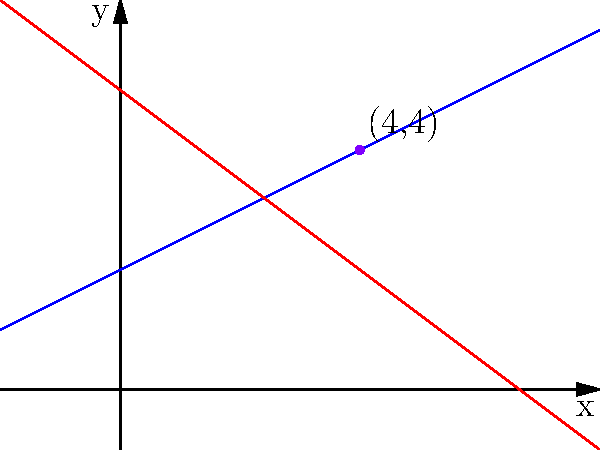In Yorgos Lanthimos' film "The Lobster," two characters' motivations can be represented by linear equations. Character A's motivation is expressed by the line $y = 0.5x + 2$, while Character B's motivation is represented by $y = -0.75x + 5$. At what point do these conflicting motivations intersect, potentially creating a pivotal moment in the narrative? To find the intersection point of the two lines representing the characters' motivations, we need to solve the system of equations:

1) $y = 0.5x + 2$ (Character A's motivation)
2) $y = -0.75x + 5$ (Character B's motivation)

At the intersection point, both equations are true. So we can set them equal to each other:

3) $0.5x + 2 = -0.75x + 5$

Now, let's solve for x:

4) $0.5x + 0.75x = 5 - 2$
5) $1.25x = 3$
6) $x = 3 / 1.25 = 2.4$

To find y, we can substitute this x-value into either of the original equations. Let's use Character A's equation:

7) $y = 0.5(2.4) + 2$
8) $y = 1.2 + 2 = 3.2$

Therefore, the intersection point is $(2.4, 3.2)$. However, in the context of film analysis, we often round to whole numbers for simplicity. Rounding both coordinates to the nearest integer gives us the point $(2, 3)$.

This point represents where the characters' conflicting motivations intersect, potentially creating a crucial moment in Lanthimos' characteristically complex and absurdist narrative structure.
Answer: $(2, 3)$ 